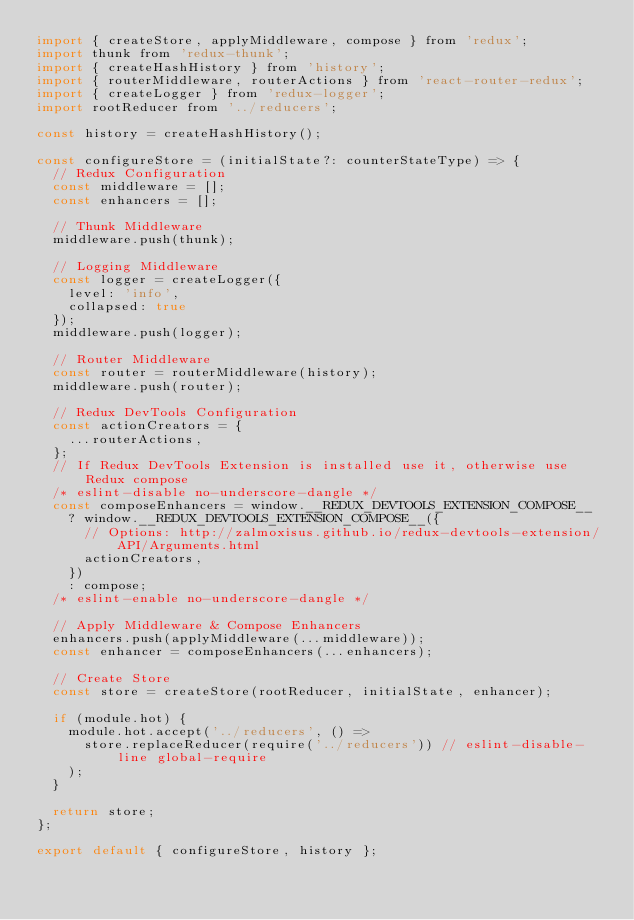Convert code to text. <code><loc_0><loc_0><loc_500><loc_500><_JavaScript_>import { createStore, applyMiddleware, compose } from 'redux';
import thunk from 'redux-thunk';
import { createHashHistory } from 'history';
import { routerMiddleware, routerActions } from 'react-router-redux';
import { createLogger } from 'redux-logger';
import rootReducer from '../reducers';

const history = createHashHistory();

const configureStore = (initialState?: counterStateType) => {
  // Redux Configuration
  const middleware = [];
  const enhancers = [];

  // Thunk Middleware
  middleware.push(thunk);

  // Logging Middleware
  const logger = createLogger({
    level: 'info',
    collapsed: true
  });
  middleware.push(logger);

  // Router Middleware
  const router = routerMiddleware(history);
  middleware.push(router);

  // Redux DevTools Configuration
  const actionCreators = {
    ...routerActions,
  };
  // If Redux DevTools Extension is installed use it, otherwise use Redux compose
  /* eslint-disable no-underscore-dangle */
  const composeEnhancers = window.__REDUX_DEVTOOLS_EXTENSION_COMPOSE__
    ? window.__REDUX_DEVTOOLS_EXTENSION_COMPOSE__({
      // Options: http://zalmoxisus.github.io/redux-devtools-extension/API/Arguments.html
      actionCreators,
    })
    : compose;
  /* eslint-enable no-underscore-dangle */

  // Apply Middleware & Compose Enhancers
  enhancers.push(applyMiddleware(...middleware));
  const enhancer = composeEnhancers(...enhancers);

  // Create Store
  const store = createStore(rootReducer, initialState, enhancer);

  if (module.hot) {
    module.hot.accept('../reducers', () =>
      store.replaceReducer(require('../reducers')) // eslint-disable-line global-require
    );
  }

  return store;
};

export default { configureStore, history };
</code> 